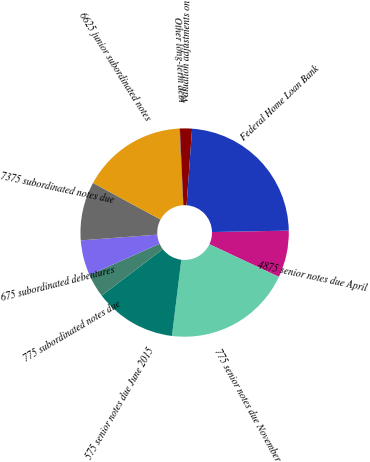Convert chart. <chart><loc_0><loc_0><loc_500><loc_500><pie_chart><fcel>4875 senior notes due April<fcel>775 senior notes due November<fcel>575 senior notes due June 2015<fcel>775 subordinated notes due<fcel>675 subordinated debentures<fcel>7375 subordinated notes due<fcel>6625 junior subordinated notes<fcel>Other long-term debt<fcel>Valuation adjustments on<fcel>Federal Home Loan Bank<nl><fcel>7.29%<fcel>19.95%<fcel>12.71%<fcel>3.67%<fcel>5.48%<fcel>9.1%<fcel>16.33%<fcel>0.05%<fcel>1.86%<fcel>23.56%<nl></chart> 